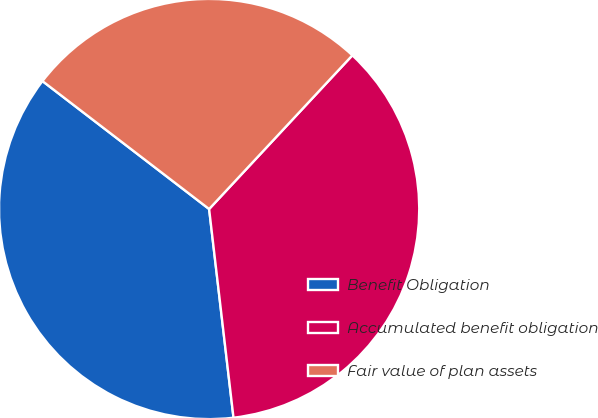Convert chart. <chart><loc_0><loc_0><loc_500><loc_500><pie_chart><fcel>Benefit Obligation<fcel>Accumulated benefit obligation<fcel>Fair value of plan assets<nl><fcel>37.27%<fcel>36.21%<fcel>26.52%<nl></chart> 